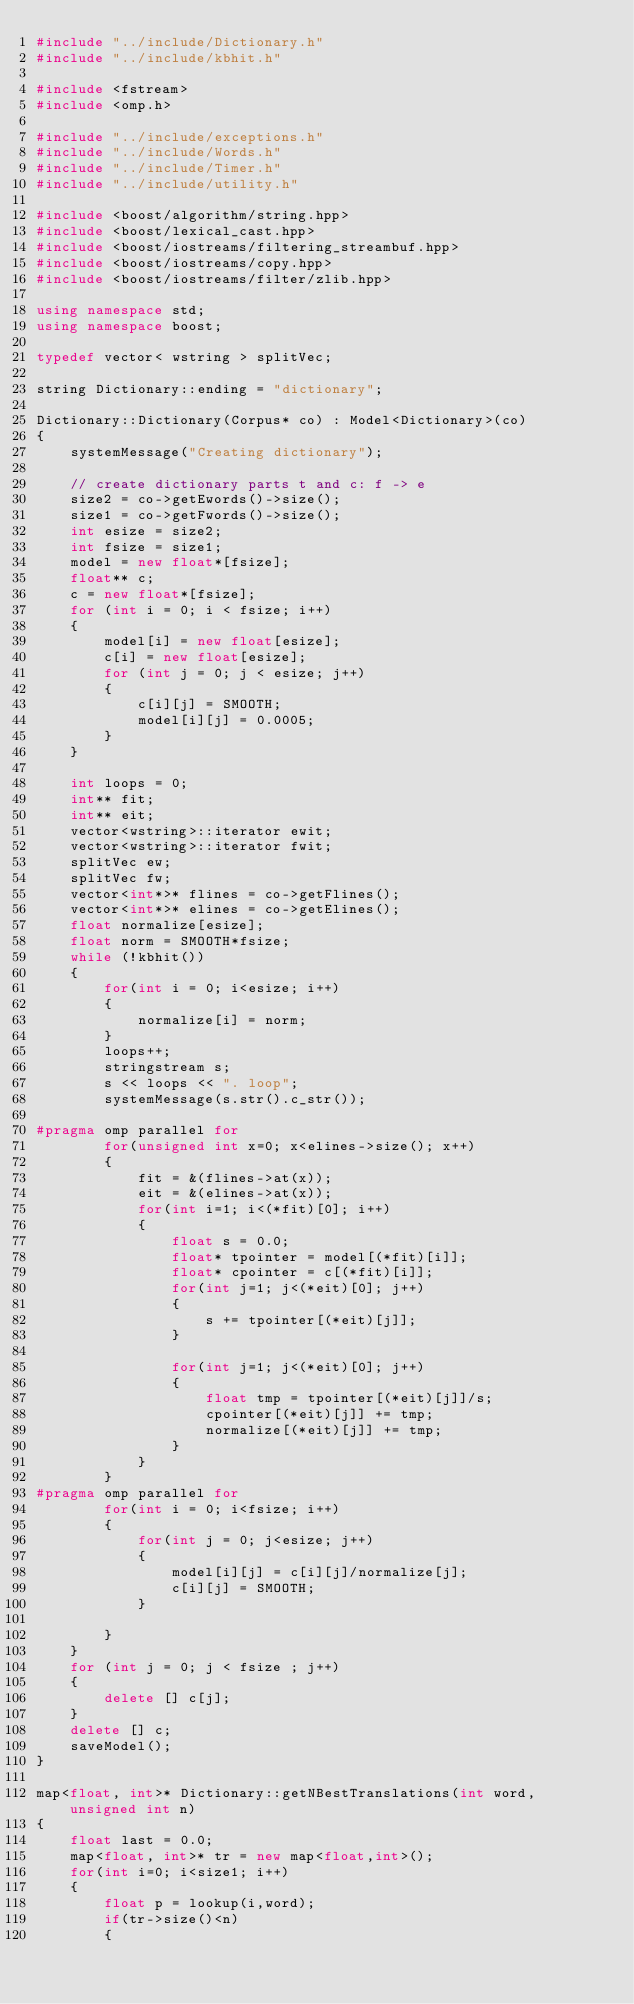Convert code to text. <code><loc_0><loc_0><loc_500><loc_500><_C++_>#include "../include/Dictionary.h"
#include "../include/kbhit.h"

#include <fstream>
#include <omp.h>

#include "../include/exceptions.h"
#include "../include/Words.h"
#include "../include/Timer.h"
#include "../include/utility.h"

#include <boost/algorithm/string.hpp>
#include <boost/lexical_cast.hpp>
#include <boost/iostreams/filtering_streambuf.hpp>
#include <boost/iostreams/copy.hpp>
#include <boost/iostreams/filter/zlib.hpp>

using namespace std;
using namespace boost;

typedef vector< wstring > splitVec;

string Dictionary::ending = "dictionary";

Dictionary::Dictionary(Corpus* co) : Model<Dictionary>(co)
{
    systemMessage("Creating dictionary");

    // create dictionary parts t and c: f -> e
    size2 = co->getEwords()->size();
    size1 = co->getFwords()->size();
    int esize = size2;
    int fsize = size1;
    model = new float*[fsize];
    float** c;
    c = new float*[fsize];
    for (int i = 0; i < fsize; i++)
    {
        model[i] = new float[esize];
        c[i] = new float[esize];
        for (int j = 0; j < esize; j++)
        {
            c[i][j] = SMOOTH;
            model[i][j] = 0.0005;
        }
    }

    int loops = 0;
    int** fit;
    int** eit;
    vector<wstring>::iterator ewit;
    vector<wstring>::iterator fwit;
    splitVec ew;
    splitVec fw;
    vector<int*>* flines = co->getFlines();
    vector<int*>* elines = co->getElines();
    float normalize[esize];
    float norm = SMOOTH*fsize;
    while (!kbhit())
    {
        for(int i = 0; i<esize; i++)
        {
            normalize[i] = norm;
        }
        loops++;
        stringstream s;
        s << loops << ". loop";
        systemMessage(s.str().c_str());

#pragma omp parallel for
        for(unsigned int x=0; x<elines->size(); x++)
        {
            fit = &(flines->at(x));
            eit = &(elines->at(x));
            for(int i=1; i<(*fit)[0]; i++)
            {
                float s = 0.0;
                float* tpointer = model[(*fit)[i]];
                float* cpointer = c[(*fit)[i]];
                for(int j=1; j<(*eit)[0]; j++)
                {
                    s += tpointer[(*eit)[j]];
                }

                for(int j=1; j<(*eit)[0]; j++)
                {
                    float tmp = tpointer[(*eit)[j]]/s;
                    cpointer[(*eit)[j]] += tmp;
                    normalize[(*eit)[j]] += tmp;
                }
            }
        }
#pragma omp parallel for
        for(int i = 0; i<fsize; i++)
        {
            for(int j = 0; j<esize; j++)
            {
                model[i][j] = c[i][j]/normalize[j];
                c[i][j] = SMOOTH;
            }

        }
    }
    for (int j = 0; j < fsize ; j++)
    {
        delete [] c[j];
    }
    delete [] c;
    saveModel();
}

map<float, int>* Dictionary::getNBestTranslations(int word, unsigned int n)
{
    float last = 0.0;
    map<float, int>* tr = new map<float,int>();
    for(int i=0; i<size1; i++)
    {
        float p = lookup(i,word);
        if(tr->size()<n)
        {</code> 